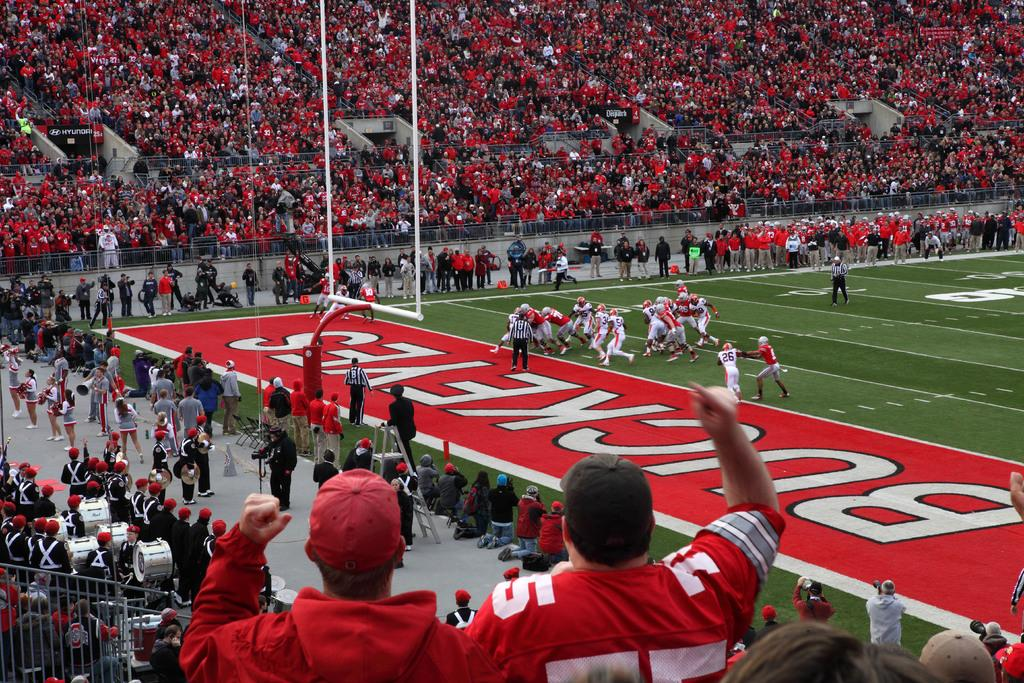<image>
Write a terse but informative summary of the picture. A football field with a bunch of players on the goal line that says buckeyes 